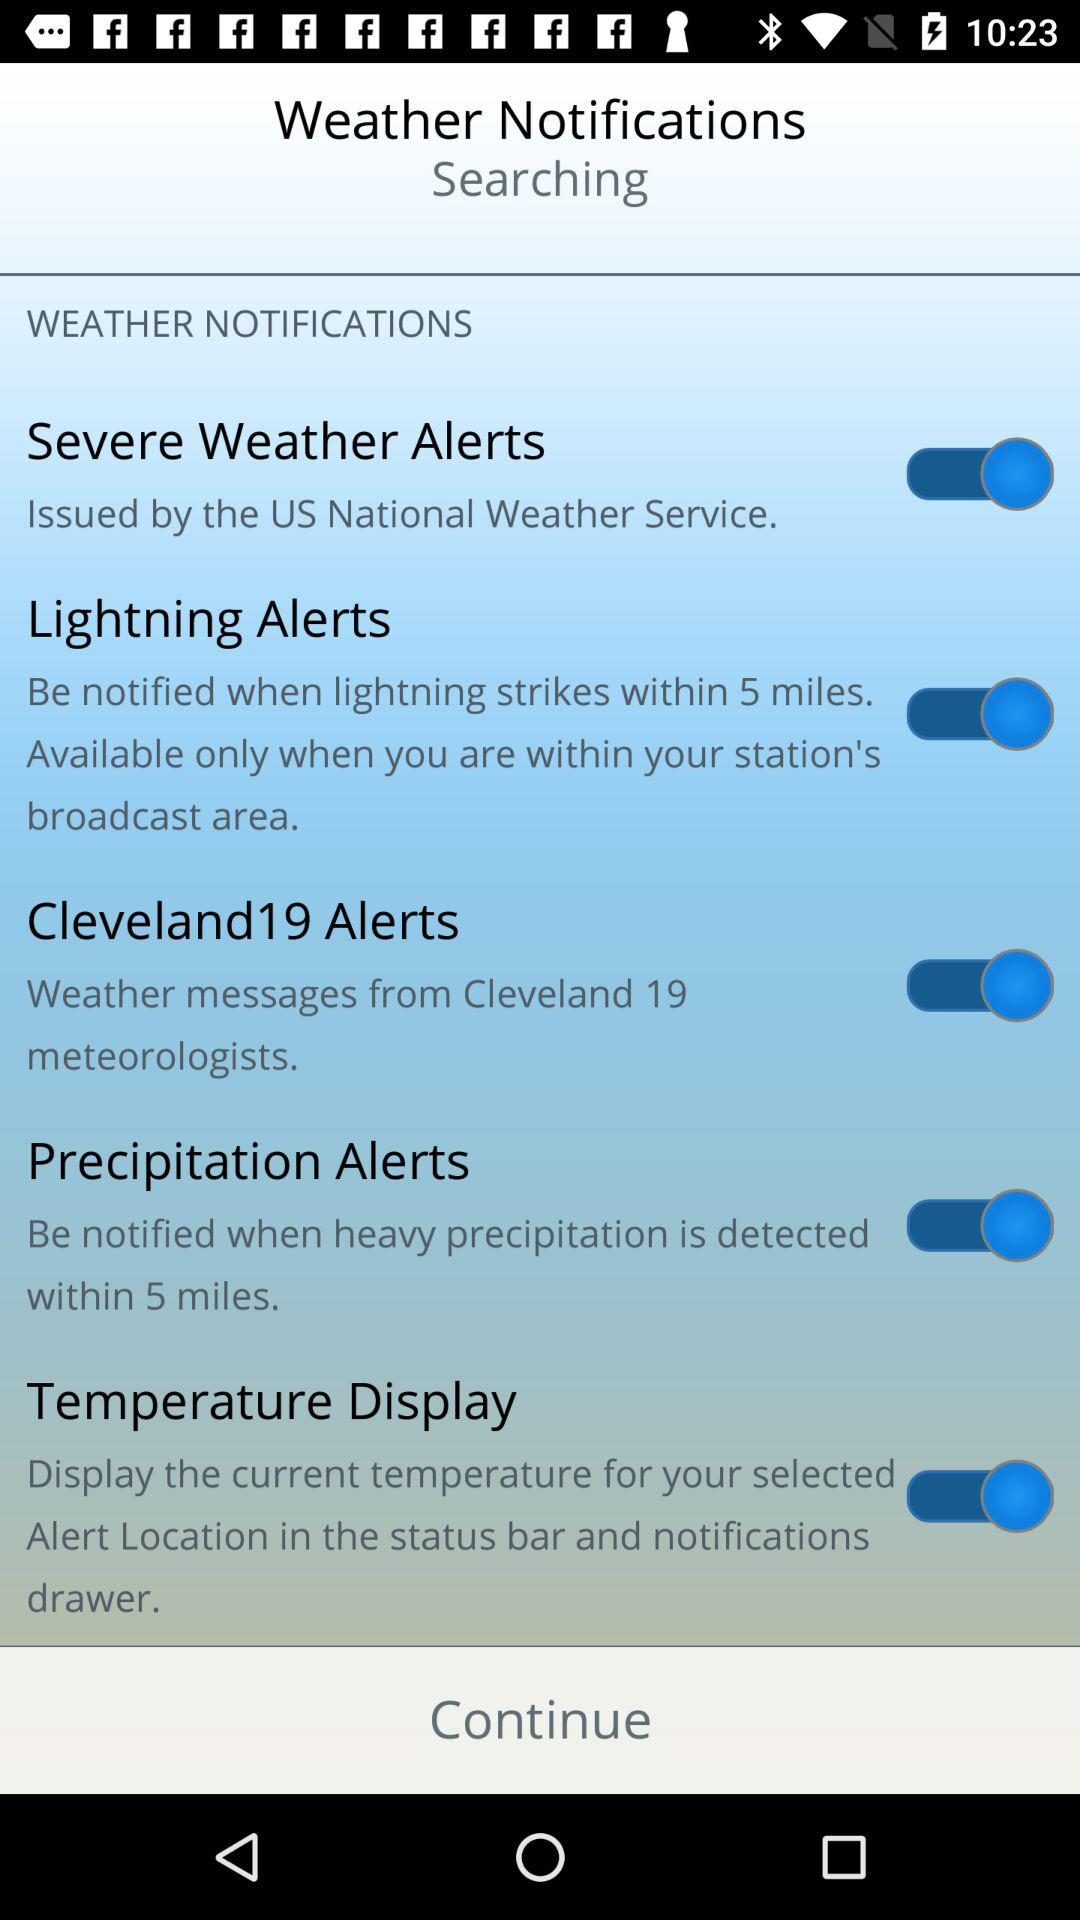What is the status of the "Severe Weather Alerts"? The status of the 'Severe Weather Alerts' is currently set to 'on,' as shown by the blue toggle being switched to the right side. This means you will receive notifications issued by the US National Weather Service regarding severe weather conditions through this alert system. 